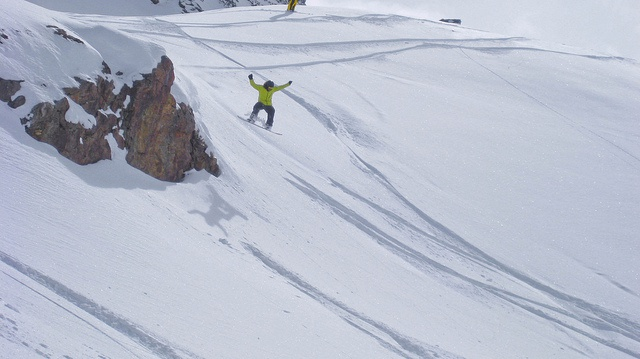Describe the objects in this image and their specific colors. I can see people in lavender, gray, olive, and darkblue tones and snowboard in lavender, darkgray, lightgray, and gray tones in this image. 